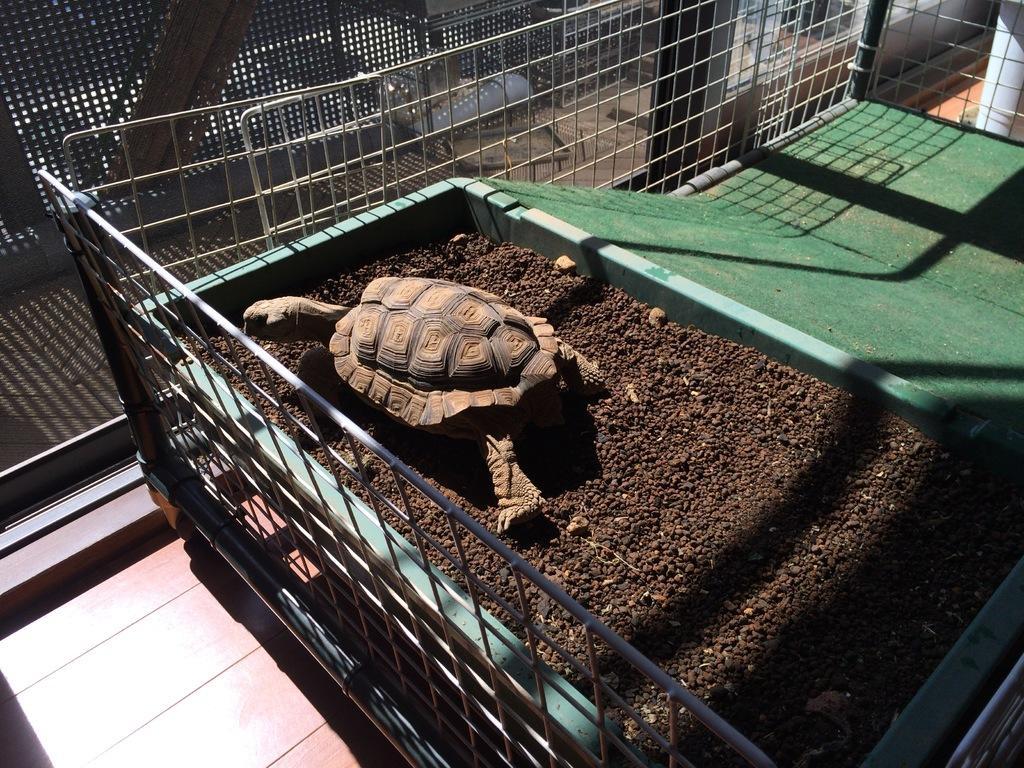How would you summarize this image in a sentence or two? Here in this picture we can see a tortoise present in a bin and we can see some place in the bin is covered with sand and other part is covered with carpet over there and we can also see a fencing beside it over there. 